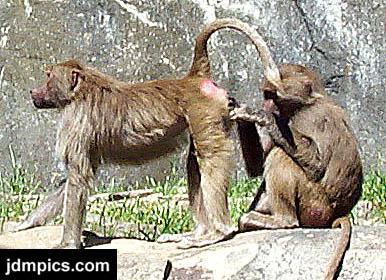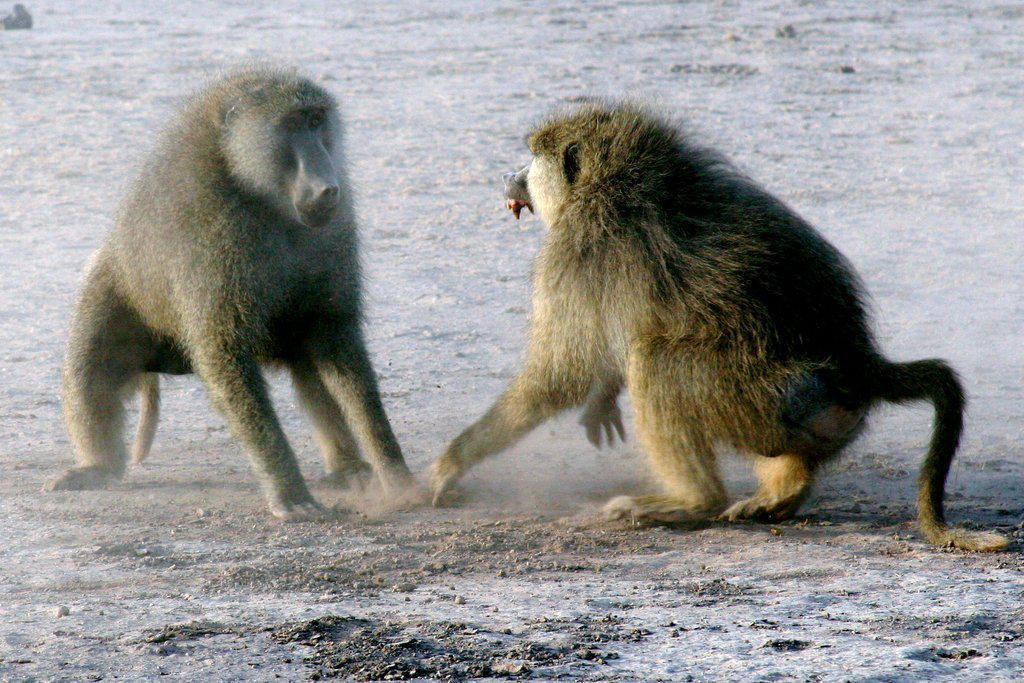The first image is the image on the left, the second image is the image on the right. Evaluate the accuracy of this statement regarding the images: "An image contains two open-mouthed monkeys posed face-to-face.". Is it true? Answer yes or no. No. The first image is the image on the left, the second image is the image on the right. Analyze the images presented: Is the assertion "A monkey is picking another's back in one of the images." valid? Answer yes or no. No. 